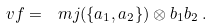Convert formula to latex. <formula><loc_0><loc_0><loc_500><loc_500>\ v f = \ m j ( \{ a _ { 1 } , a _ { 2 } \} ) \otimes b _ { 1 } b _ { 2 } \, .</formula> 